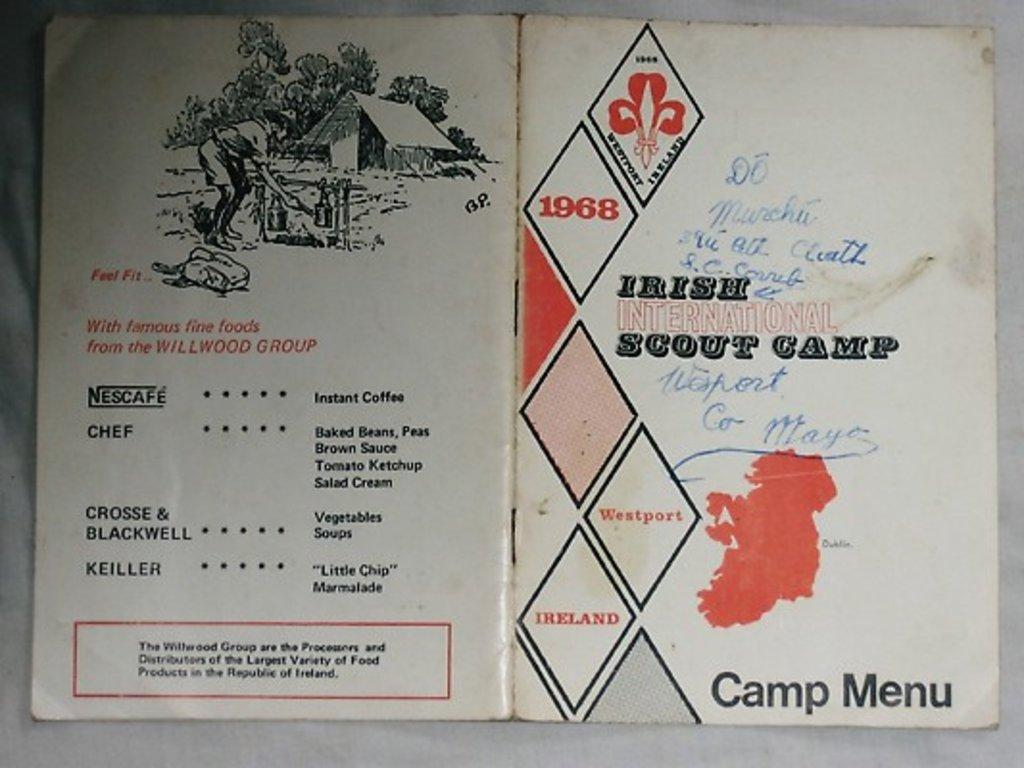What is present on the poster in the image? The poster has text and images. What is the color of the surface the poster is placed on? The surface the poster is placed on is white colored. How does the comb affect the poster in the image? There is no comb present in the image, so it cannot affect the poster. 